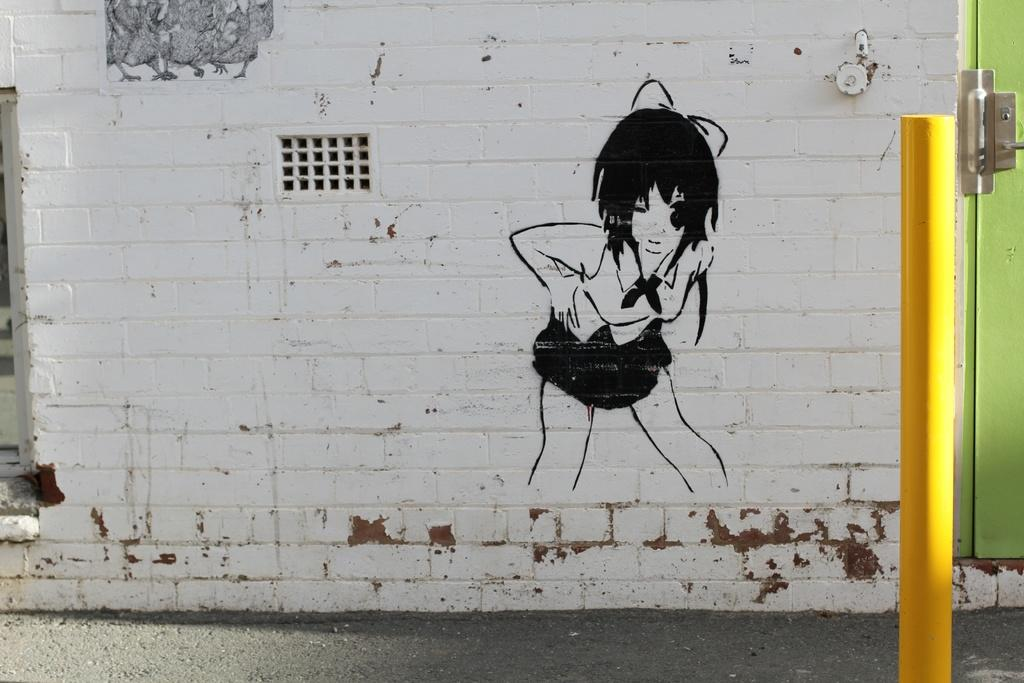What is the main subject of the image? There is a painting in the image. What architectural feature can be seen on a wall in the image? There is a window on a wall in the image. What is located on the right side of the image? There is a door on the right side of the image. What object can be seen in the image that stands upright and is not attached to any structure? There is a pole in the image. How many chickens are visible in the painting in the image? There are no chickens visible in the painting or the image. What type of quilt is draped over the pole in the image? There is no quilt present in the image. 